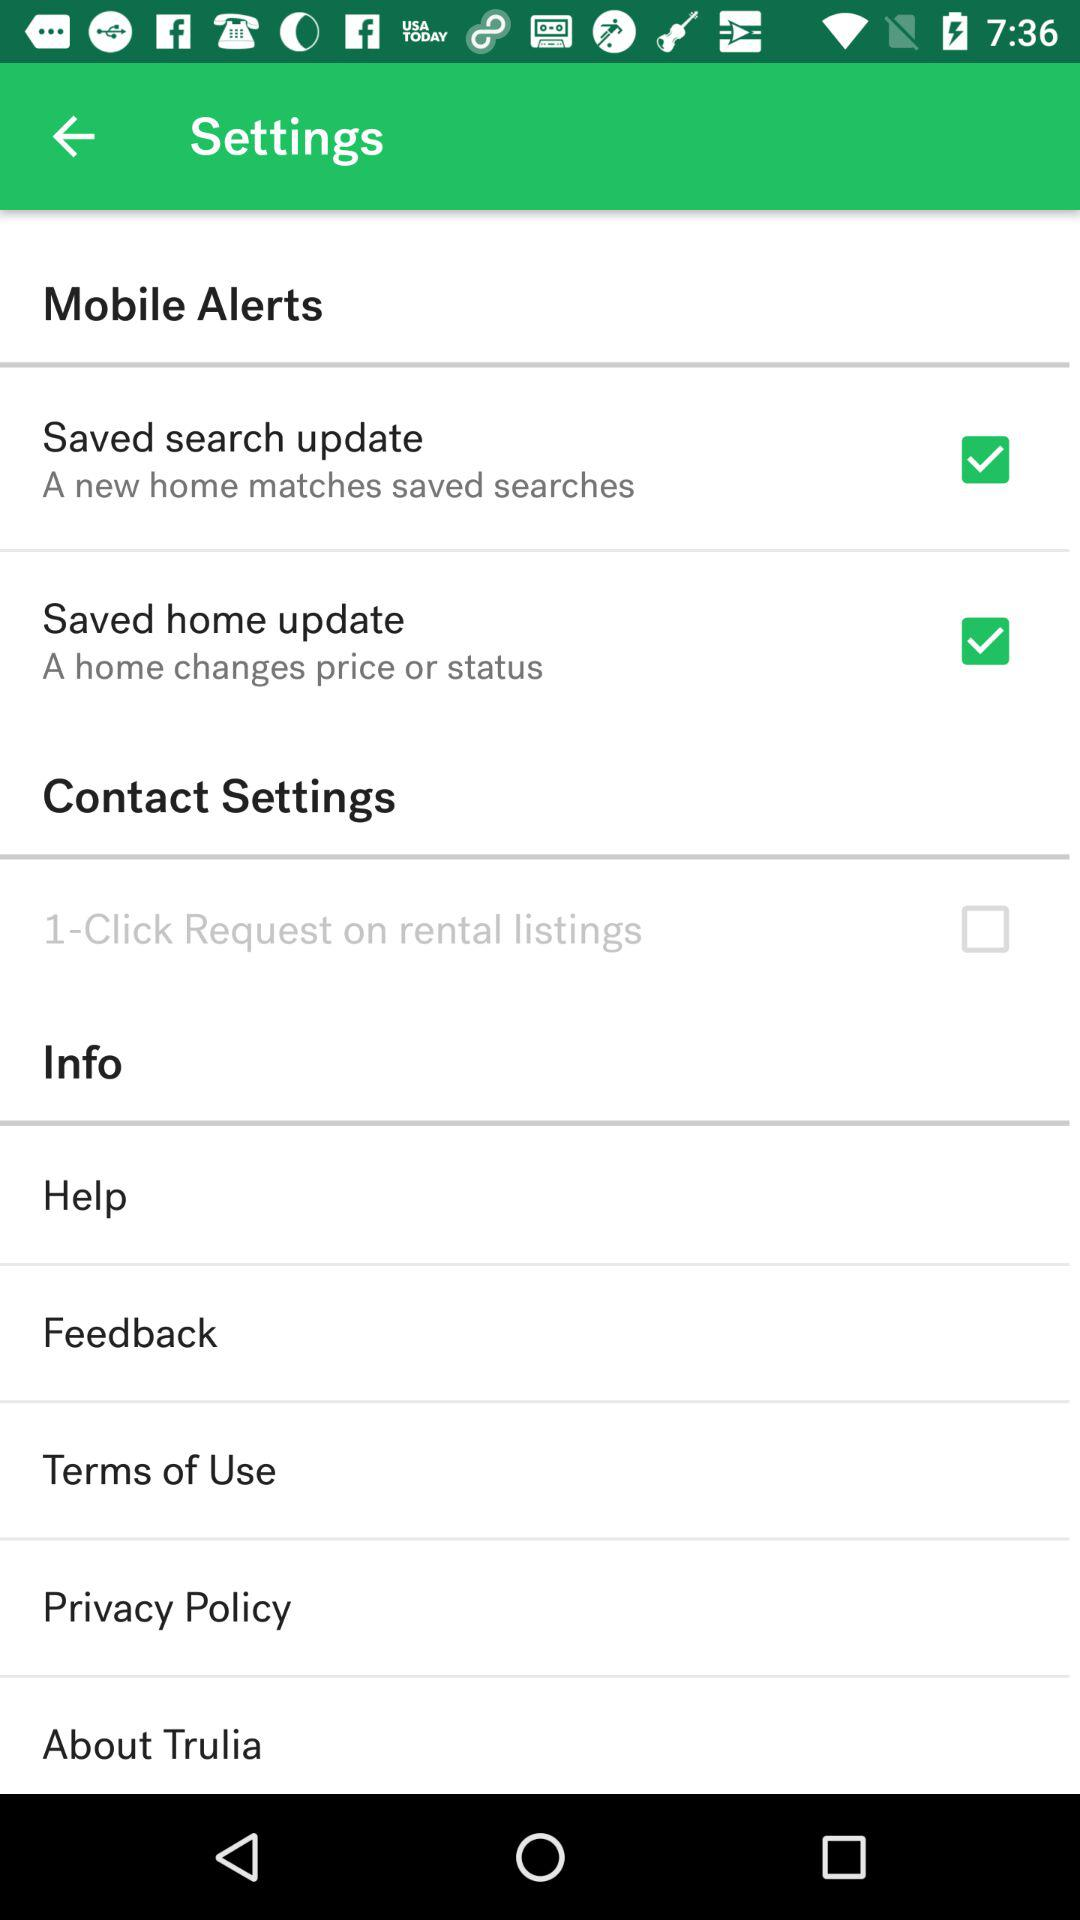What is the status of "Saved search update"? The status is "on". 